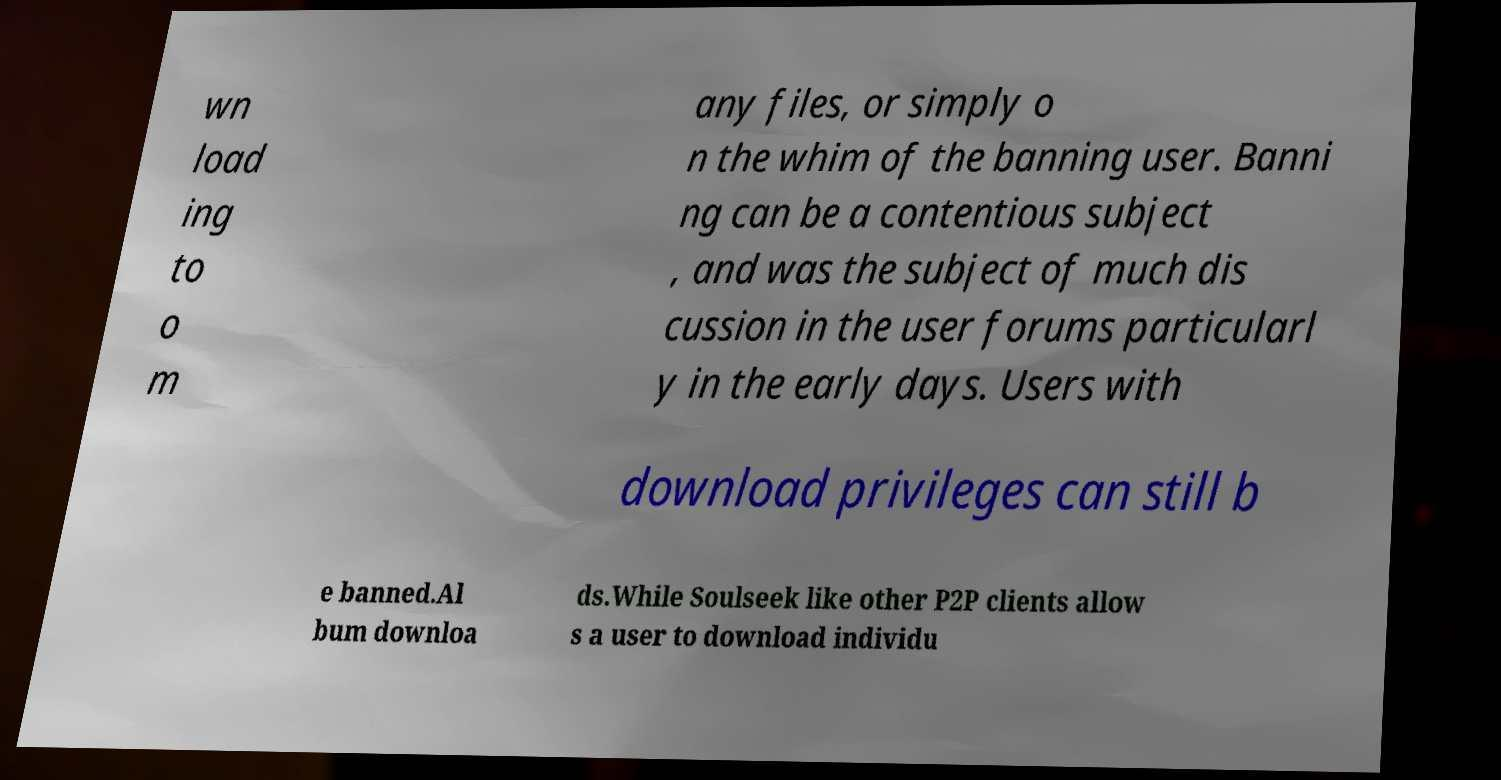For documentation purposes, I need the text within this image transcribed. Could you provide that? wn load ing to o m any files, or simply o n the whim of the banning user. Banni ng can be a contentious subject , and was the subject of much dis cussion in the user forums particularl y in the early days. Users with download privileges can still b e banned.Al bum downloa ds.While Soulseek like other P2P clients allow s a user to download individu 